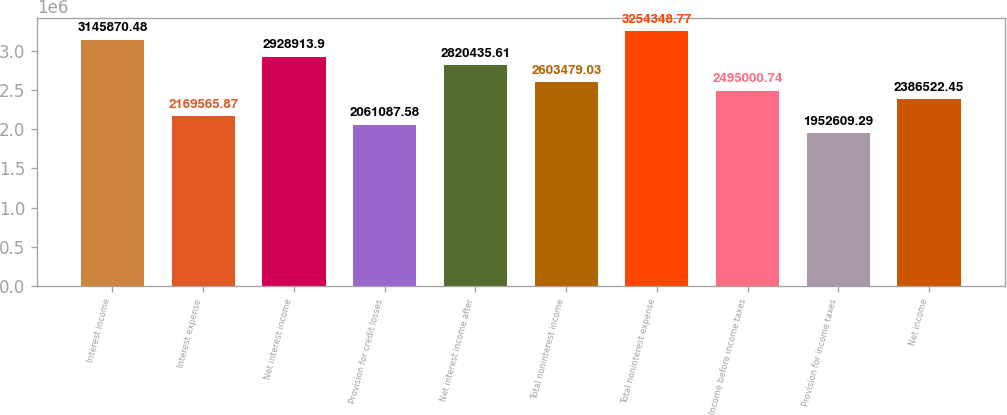Convert chart to OTSL. <chart><loc_0><loc_0><loc_500><loc_500><bar_chart><fcel>Interest income<fcel>Interest expense<fcel>Net interest income<fcel>Provision for credit losses<fcel>Net interest income after<fcel>Total noninterest income<fcel>Total noninterest expense<fcel>Income before income taxes<fcel>Provision for income taxes<fcel>Net income<nl><fcel>3.14587e+06<fcel>2.16957e+06<fcel>2.92891e+06<fcel>2.06109e+06<fcel>2.82044e+06<fcel>2.60348e+06<fcel>3.25435e+06<fcel>2.495e+06<fcel>1.95261e+06<fcel>2.38652e+06<nl></chart> 